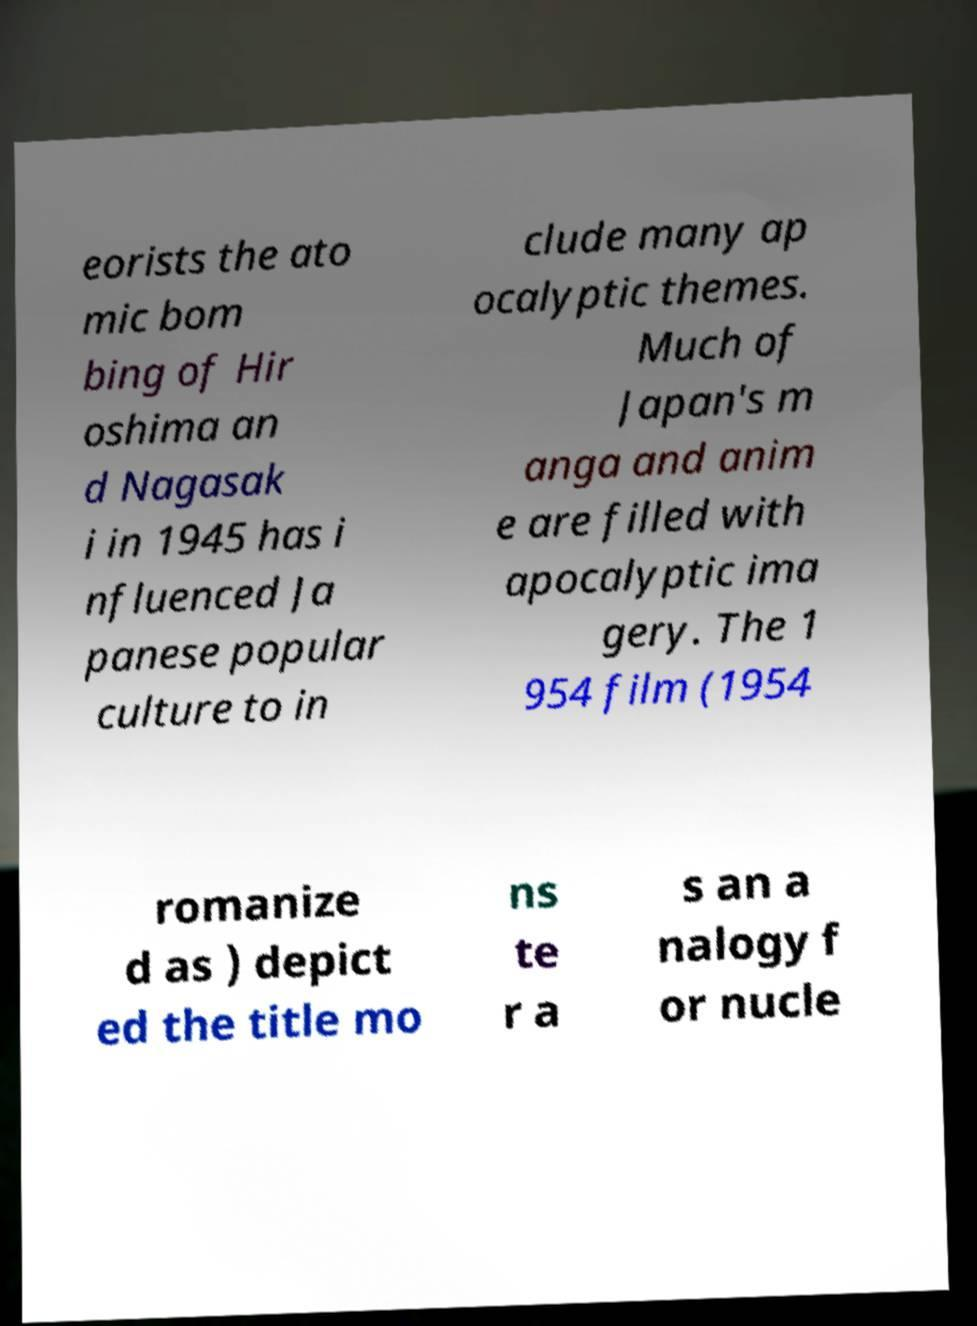There's text embedded in this image that I need extracted. Can you transcribe it verbatim? eorists the ato mic bom bing of Hir oshima an d Nagasak i in 1945 has i nfluenced Ja panese popular culture to in clude many ap ocalyptic themes. Much of Japan's m anga and anim e are filled with apocalyptic ima gery. The 1 954 film (1954 romanize d as ) depict ed the title mo ns te r a s an a nalogy f or nucle 